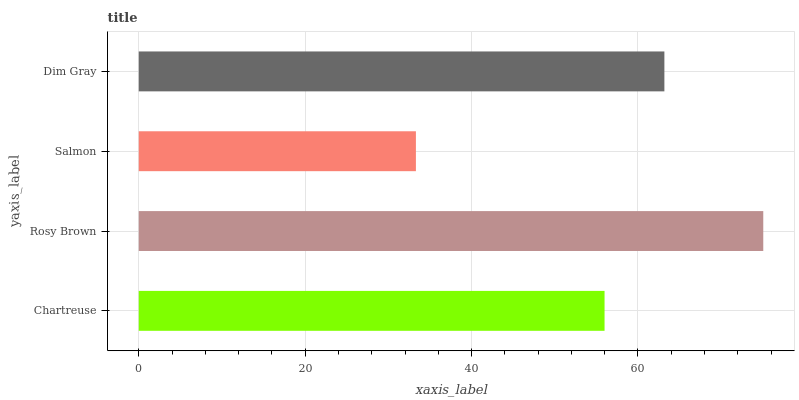Is Salmon the minimum?
Answer yes or no. Yes. Is Rosy Brown the maximum?
Answer yes or no. Yes. Is Rosy Brown the minimum?
Answer yes or no. No. Is Salmon the maximum?
Answer yes or no. No. Is Rosy Brown greater than Salmon?
Answer yes or no. Yes. Is Salmon less than Rosy Brown?
Answer yes or no. Yes. Is Salmon greater than Rosy Brown?
Answer yes or no. No. Is Rosy Brown less than Salmon?
Answer yes or no. No. Is Dim Gray the high median?
Answer yes or no. Yes. Is Chartreuse the low median?
Answer yes or no. Yes. Is Salmon the high median?
Answer yes or no. No. Is Dim Gray the low median?
Answer yes or no. No. 